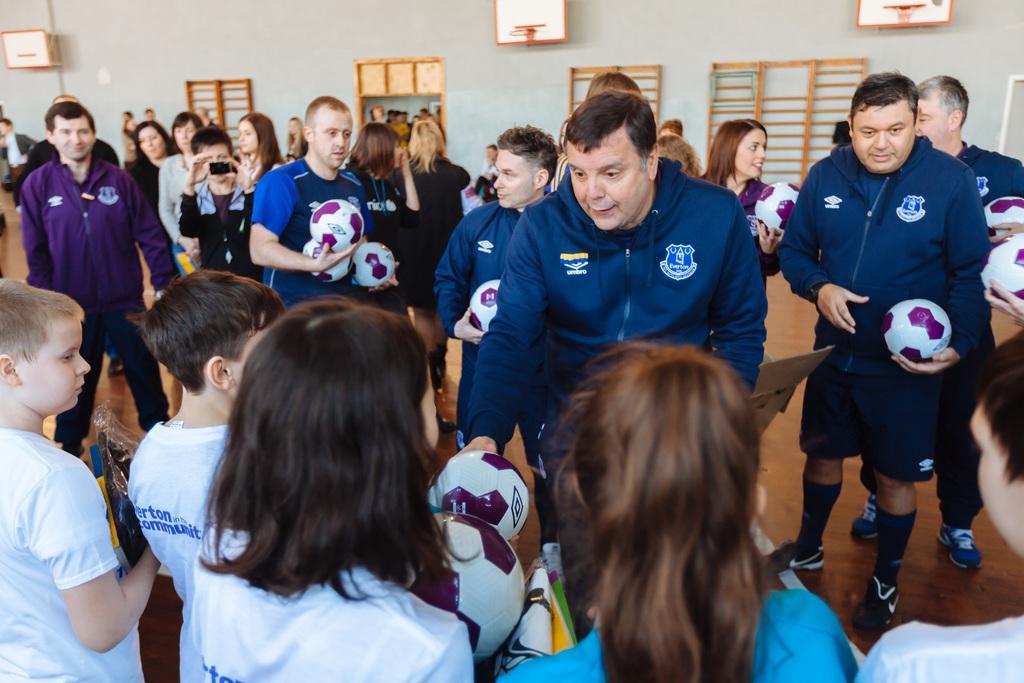Describe this image in one or two sentences. There is a group of people. They are holding a ball. We can see the background is door and window. 